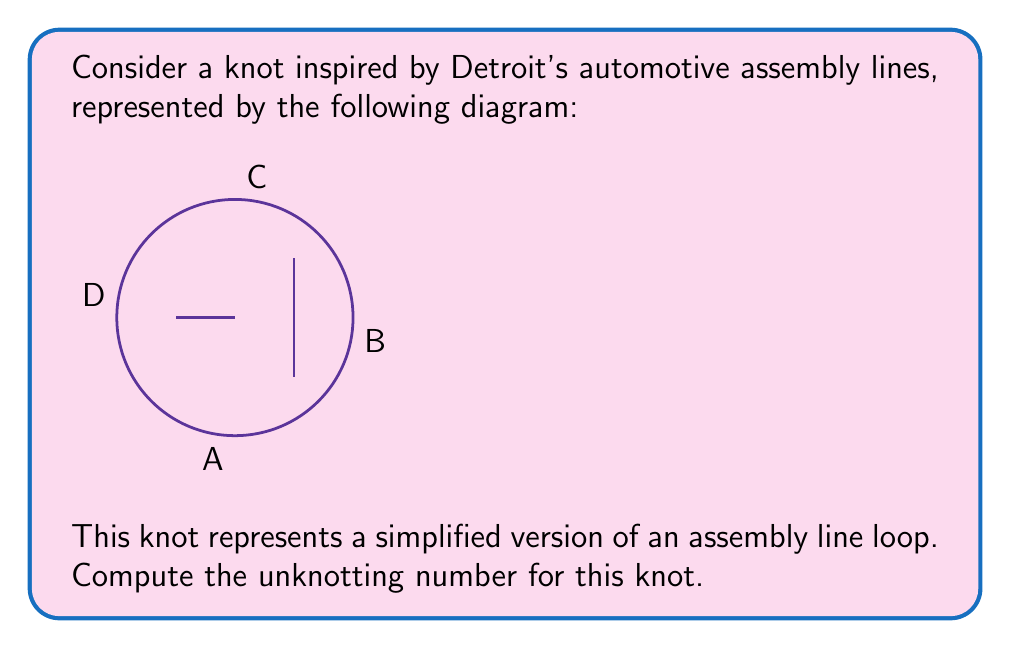Could you help me with this problem? To determine the unknotting number of this knot, we need to follow these steps:

1) First, we need to identify the crossings in the knot diagram. There are three crossings in this representation.

2) Next, we need to determine the minimum number of crossing changes required to transform this knot into the unknot (a simple closed loop with no crossings).

3) Let's analyze each crossing:
   - The crossing at point A can be resolved by changing it from an overcrossing to an undercrossing or vice versa.
   - The crossing at point B is already in a configuration that allows the loop to be untangled.
   - The crossing at point C, similar to A, needs to be changed.

4) After changing the crossings at A and C, we can see that the knot can be deformed into a simple closed loop without any crossings.

5) The unknotting number is defined as the minimum number of crossing changes required to transform the knot into the unknot.

6) In this case, we needed to change 2 crossings (at points A and C) to unknot the assembly line-inspired knot.

Therefore, the unknotting number for this knot is 2.
Answer: 2 